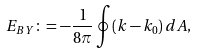<formula> <loc_0><loc_0><loc_500><loc_500>E _ { B Y } \colon = - \frac { 1 } { 8 \pi } \oint ( k - k _ { 0 } ) \, d A ,</formula> 